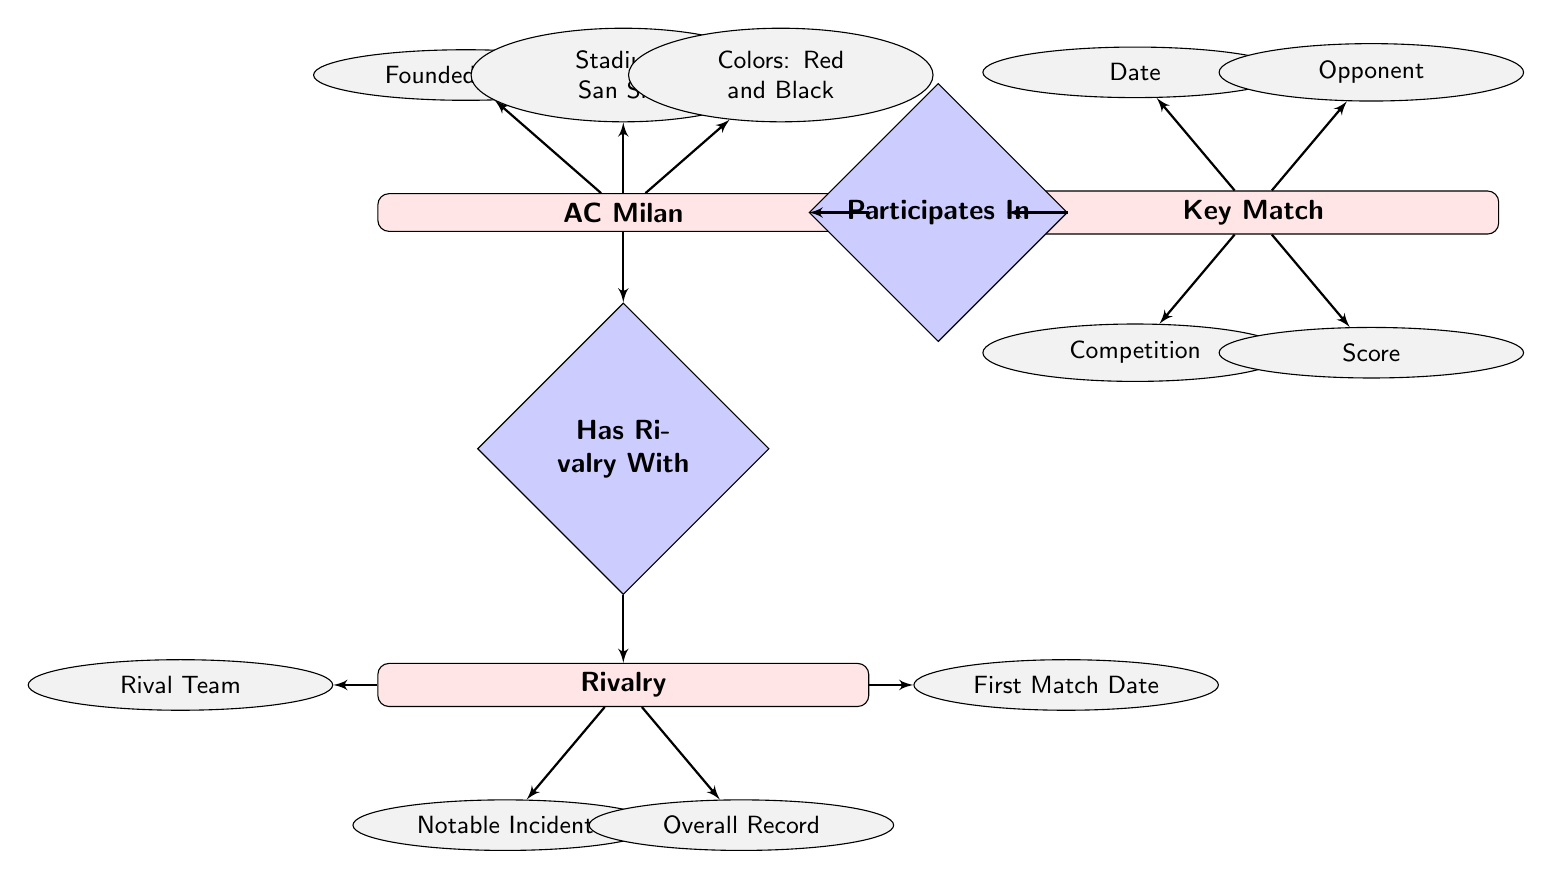What year was AC Milan founded? The attribute for AC Milan indicates it was founded in 1899.
Answer: 1899 What is the home stadium of AC Milan? The attribute for AC Milan states the stadium is San Siro.
Answer: San Siro Who is a key rival of AC Milan? The Rivalry entity shows that Inter Milan is listed as a rivalry.
Answer: Inter Milan What notable incident occurred in the AC Milan and Inter Milan rivalry? The Rivalry entity includes the notable incident "1967 'Lamp Incident'."
Answer: 1967 'Lamp Incident' How many key matches are provided as examples? Looking at the Key Match examples section, there are 2 matches listed.
Answer: 2 What was the date of the key match between AC Milan and Steaua Bucharest? The Key Match example lists the date as "1989-05-24".
Answer: 1989-05-24 What overall record does AC Milan have against Juventus? The Rivalry entity shows the overall record against Juventus as "Winner: AC Milan (51), Draw: (54), Winner: Juventus (66)."
Answer: Winner: AC Milan (51), Draw: (54), Winner: Juventus (66) How many attributes does the Key Match entity have? The Key Match entity has 4 attributes listed: Date, Opponent, Competition, and Score.
Answer: 4 Which competition is associated with the key match dated 2003-05-28? The particular match example shows that the competition is UEFA Champions League Final.
Answer: UEFA Champions League Final 